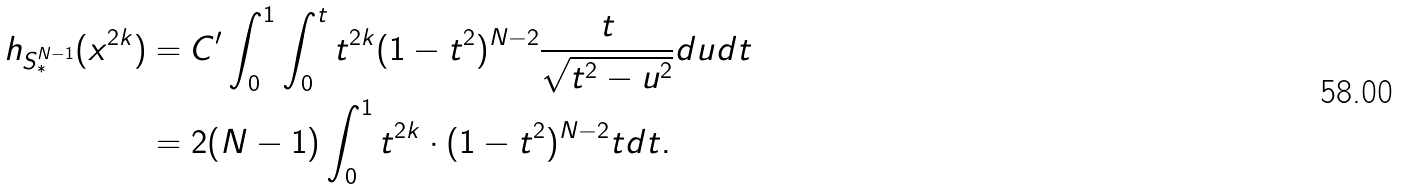Convert formula to latex. <formula><loc_0><loc_0><loc_500><loc_500>h _ { S ^ { N - 1 } _ { * } } ( x ^ { 2 k } ) & = C ^ { \prime } \int _ { 0 } ^ { 1 } \int _ { 0 } ^ { t } t ^ { 2 k } ( 1 - t ^ { 2 } ) ^ { N - 2 } \frac { t } { \sqrt { t ^ { 2 } - u ^ { 2 } } } d u d t \\ & = 2 ( N - 1 ) \int _ { 0 } ^ { 1 } t ^ { 2 k } \cdot ( 1 - t ^ { 2 } ) ^ { N - 2 } t d t .</formula> 